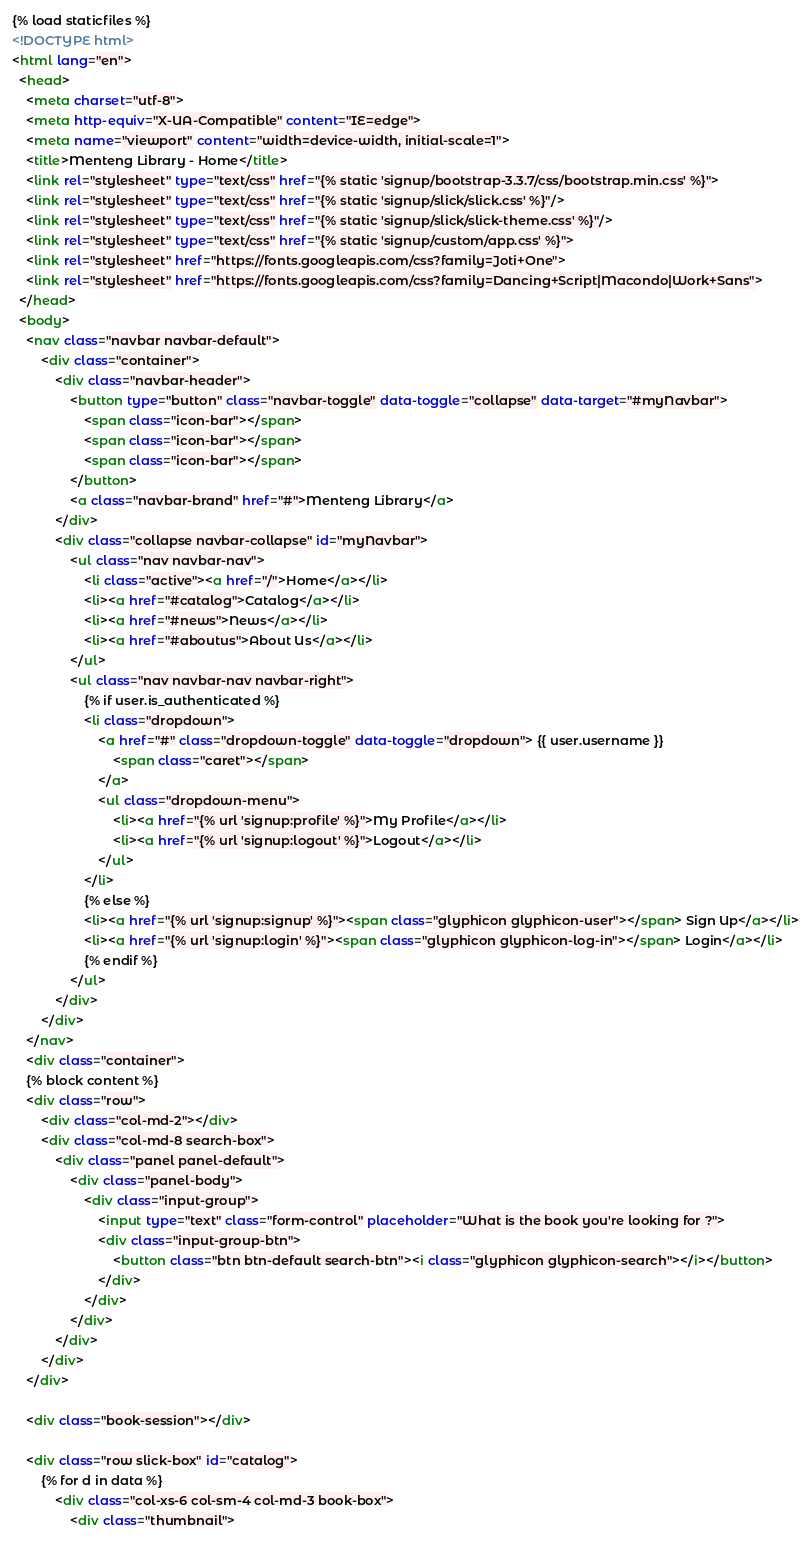Convert code to text. <code><loc_0><loc_0><loc_500><loc_500><_HTML_>{% load staticfiles %}
<!DOCTYPE html>
<html lang="en">
  <head>
    <meta charset="utf-8">
    <meta http-equiv="X-UA-Compatible" content="IE=edge">
    <meta name="viewport" content="width=device-width, initial-scale=1">
    <title>Menteng Library - Home</title>
    <link rel="stylesheet" type="text/css" href="{% static 'signup/bootstrap-3.3.7/css/bootstrap.min.css' %}">
    <link rel="stylesheet" type="text/css" href="{% static 'signup/slick/slick.css' %}"/>
    <link rel="stylesheet" type="text/css" href="{% static 'signup/slick/slick-theme.css' %}"/>
    <link rel="stylesheet" type="text/css" href="{% static 'signup/custom/app.css' %}">
    <link rel="stylesheet" href="https://fonts.googleapis.com/css?family=Joti+One">
    <link rel="stylesheet" href="https://fonts.googleapis.com/css?family=Dancing+Script|Macondo|Work+Sans">
  </head>
  <body>
    <nav class="navbar navbar-default">
        <div class="container">
            <div class="navbar-header">
                <button type="button" class="navbar-toggle" data-toggle="collapse" data-target="#myNavbar">
                    <span class="icon-bar"></span>
                    <span class="icon-bar"></span>
                    <span class="icon-bar"></span> 
                </button>
                <a class="navbar-brand" href="#">Menteng Library</a>
            </div>
            <div class="collapse navbar-collapse" id="myNavbar">
                <ul class="nav navbar-nav">
                    <li class="active"><a href="/">Home</a></li>
                    <li><a href="#catalog">Catalog</a></li>
                    <li><a href="#news">News</a></li>
                    <li><a href="#aboutus">About Us</a></li>
                </ul>
                <ul class="nav navbar-nav navbar-right">
                    {% if user.is_authenticated %}
                    <li class="dropdown">
                        <a href="#" class="dropdown-toggle" data-toggle="dropdown"> {{ user.username }}
                            <span class="caret"></span>
                        </a>
                        <ul class="dropdown-menu">
                            <li><a href="{% url 'signup:profile' %}">My Profile</a></li>
                            <li><a href="{% url 'signup:logout' %}">Logout</a></li>
                        </ul>
                    </li>
                    {% else %}
                    <li><a href="{% url 'signup:signup' %}"><span class="glyphicon glyphicon-user"></span> Sign Up</a></li>
                    <li><a href="{% url 'signup:login' %}"><span class="glyphicon glyphicon-log-in"></span> Login</a></li>
                    {% endif %}
                </ul>
            </div>
        </div>
    </nav>
    <div class="container">
    {% block content %}
    <div class="row">
        <div class="col-md-2"></div>
        <div class="col-md-8 search-box">
            <div class="panel panel-default">
                <div class="panel-body">
                    <div class="input-group">
                        <input type="text" class="form-control" placeholder="What is the book you're looking for ?">
                        <div class="input-group-btn">
                            <button class="btn btn-default search-btn"><i class="glyphicon glyphicon-search"></i></button>
                        </div>
                    </div>
                </div>
            </div>
        </div>
    </div>

    <div class="book-session"></div>

    <div class="row slick-box" id="catalog">
        {% for d in data %}
            <div class="col-xs-6 col-sm-4 col-md-3 book-box">
                <div class="thumbnail"></code> 